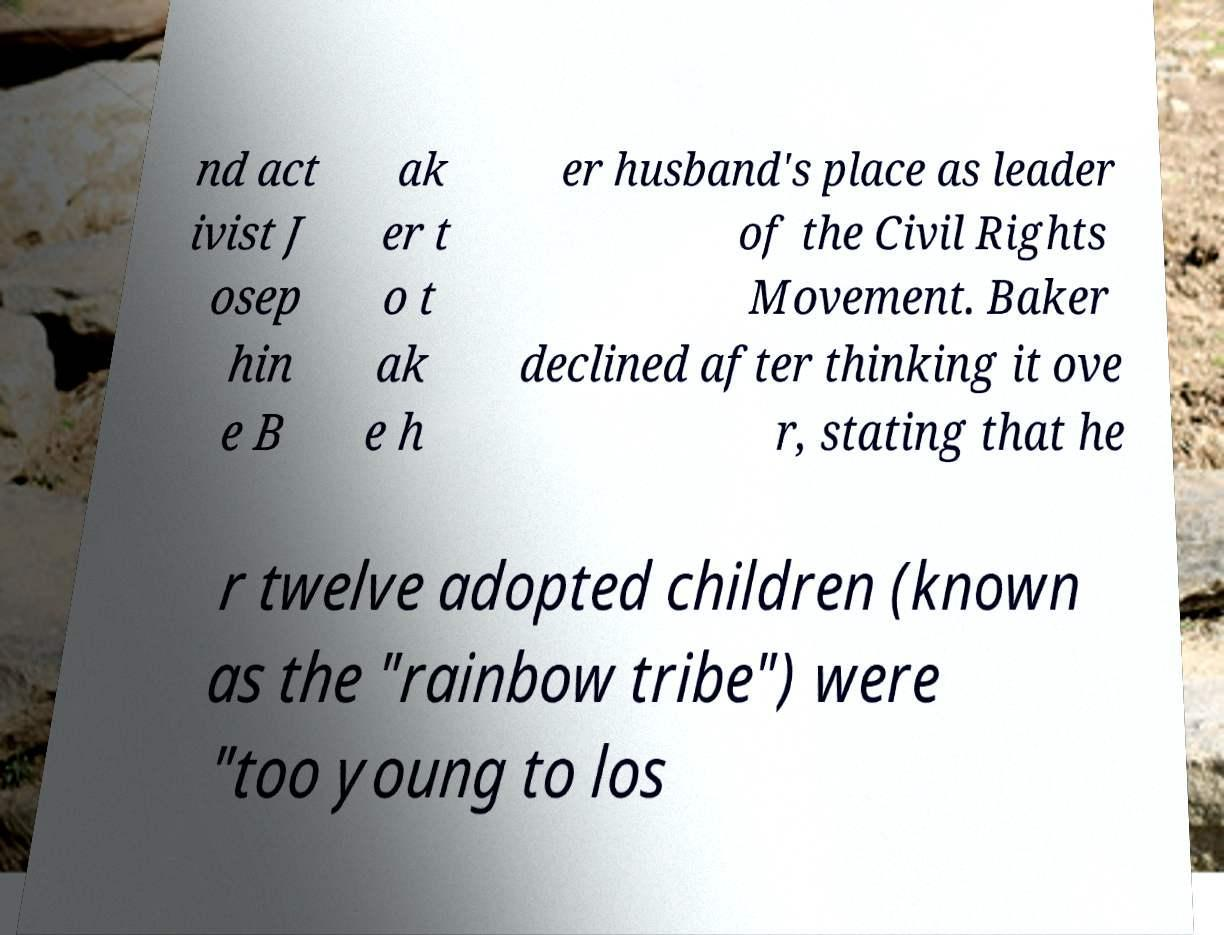Can you accurately transcribe the text from the provided image for me? nd act ivist J osep hin e B ak er t o t ak e h er husband's place as leader of the Civil Rights Movement. Baker declined after thinking it ove r, stating that he r twelve adopted children (known as the "rainbow tribe") were "too young to los 